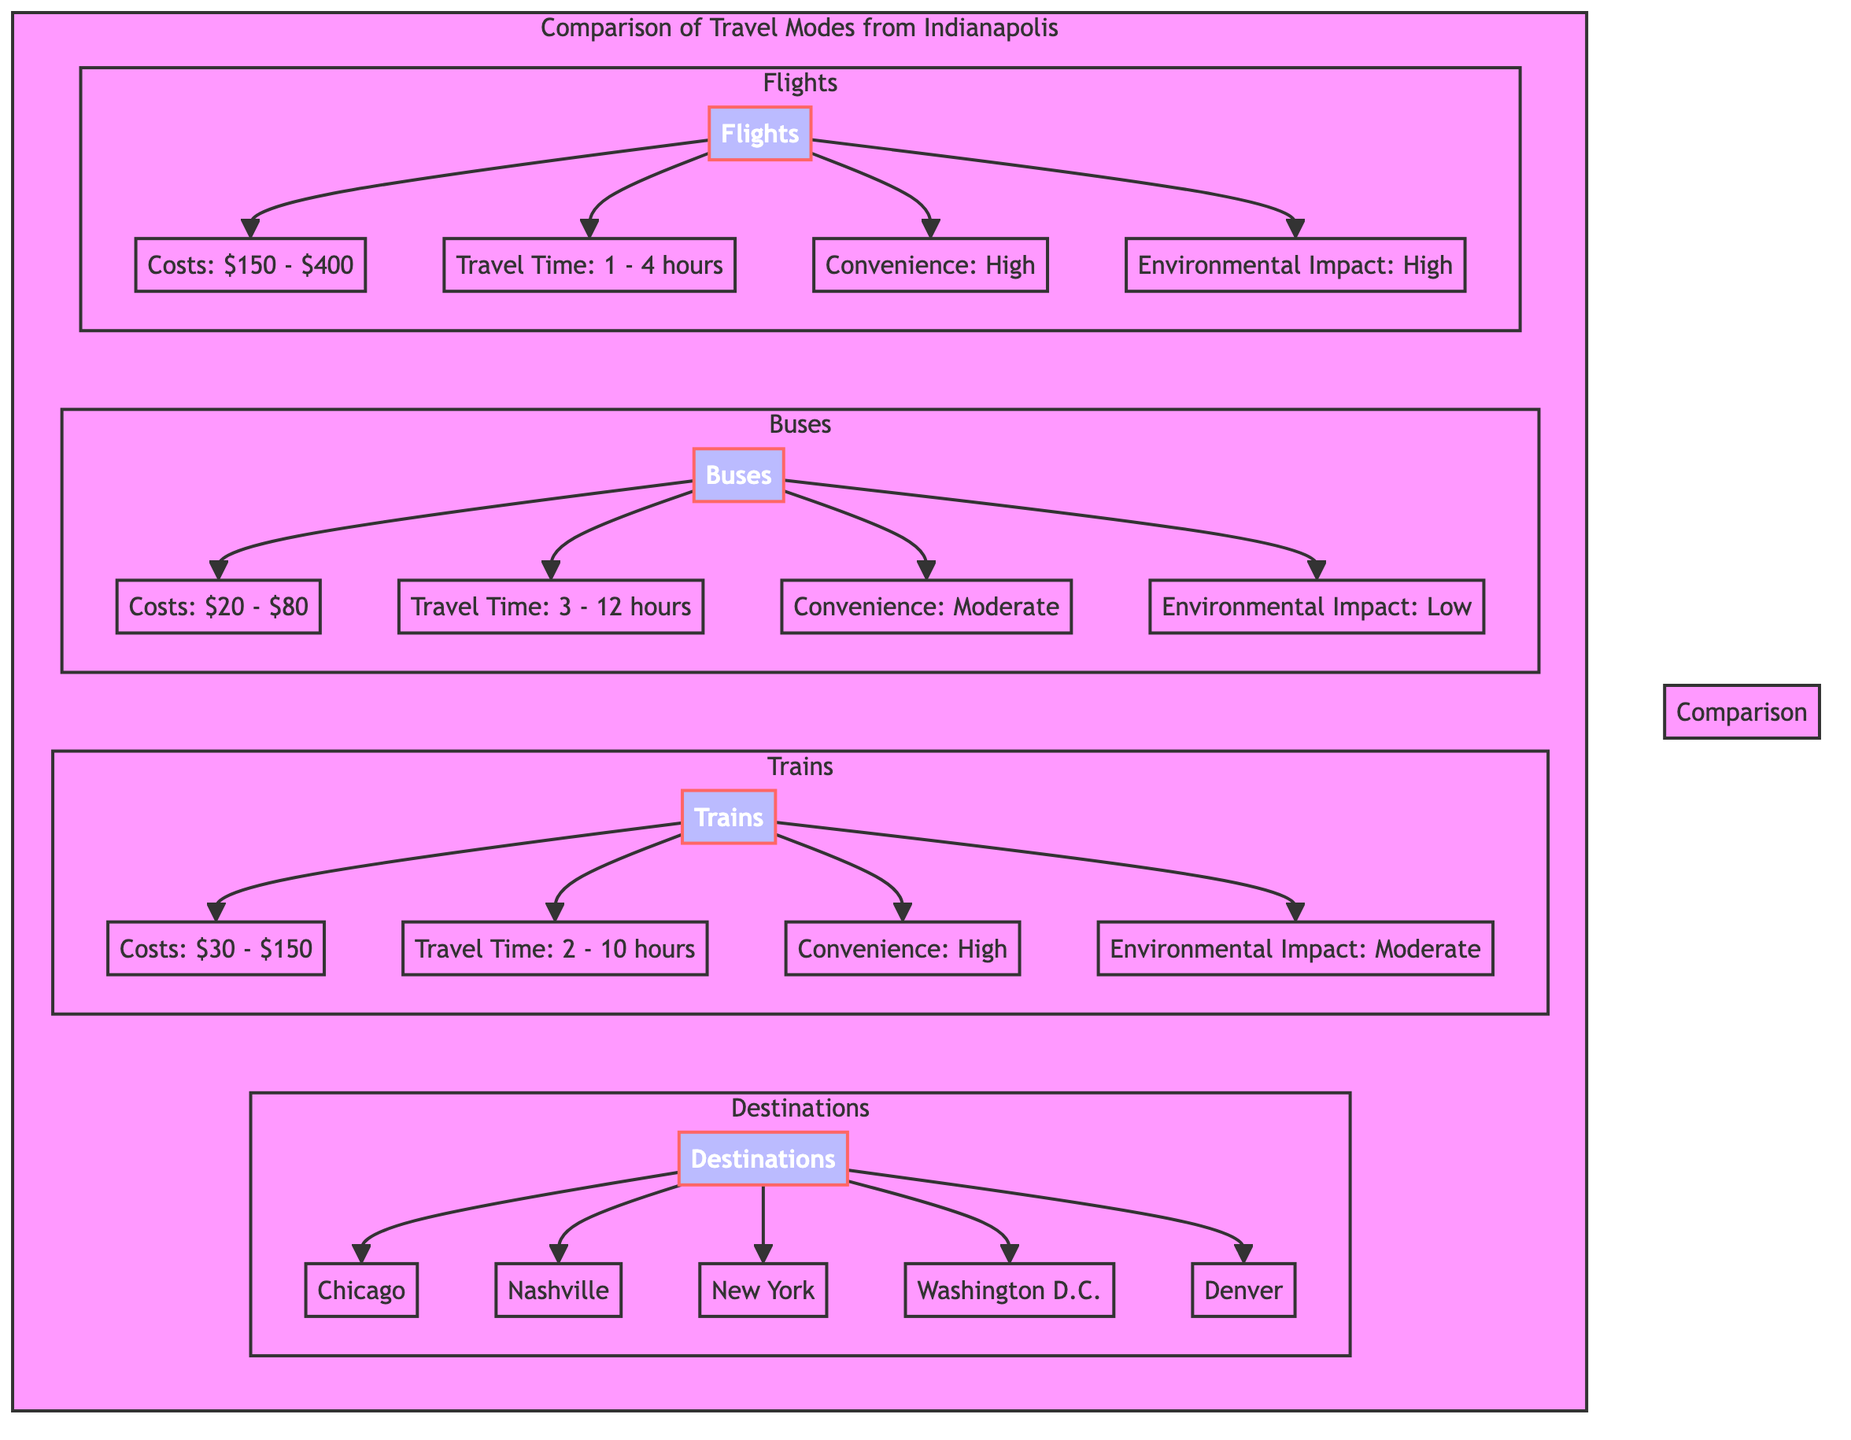What is the cost range for trains? The diagram indicates that the cost range for trains is listed as $30 - $150. To find this, I looked directly under the "Trains" subsection where costs are specified.
Answer: $30 - $150 What is the environmental impact of buses? The diagram shows that the environmental impact of buses is categorized as low. This information is found directly under the "Buses" section of the diagram.
Answer: Low Which travel mode has the highest convenience? According to the diagram, flights and trains are both categorized as high in convenience, but flights are indicated first. Thus, flights have the highest convenience. I identified this by comparing the convenience levels of each travel mode.
Answer: High How long does it take to travel to New York by bus? The diagram specifies a travel time range for buses of 3 - 12 hours, which applies to any destination, including New York. This is determined by examining the travel time listed under the "Buses" subsection.
Answer: 3 - 12 hours How many destinations are listed in the diagram? The diagram lists a total of five destinations: Chicago, Nashville, New York, Washington D.C., and Denver. To answer this, I counted the destinations listed in the "Destinations" section of the diagram.
Answer: 5 Which travel mode has the lowest cost? The diagram shows that buses have the lowest cost range of $20 - $80 compared to flights and trains. This is determined by comparing the cost sections of all three travel modes.
Answer: Buses What is the travel time range for flights? The travel time range for flights is specified as 1 - 4 hours in the diagram. I deduced this by checking the travel time indicated under the "Flights" section.
Answer: 1 - 4 hours What is the environmental impact of trains? The diagram indicates that the environmental impact of trains is classified as moderate. This information can be found directly under the "Trains" subsection.
Answer: Moderate 